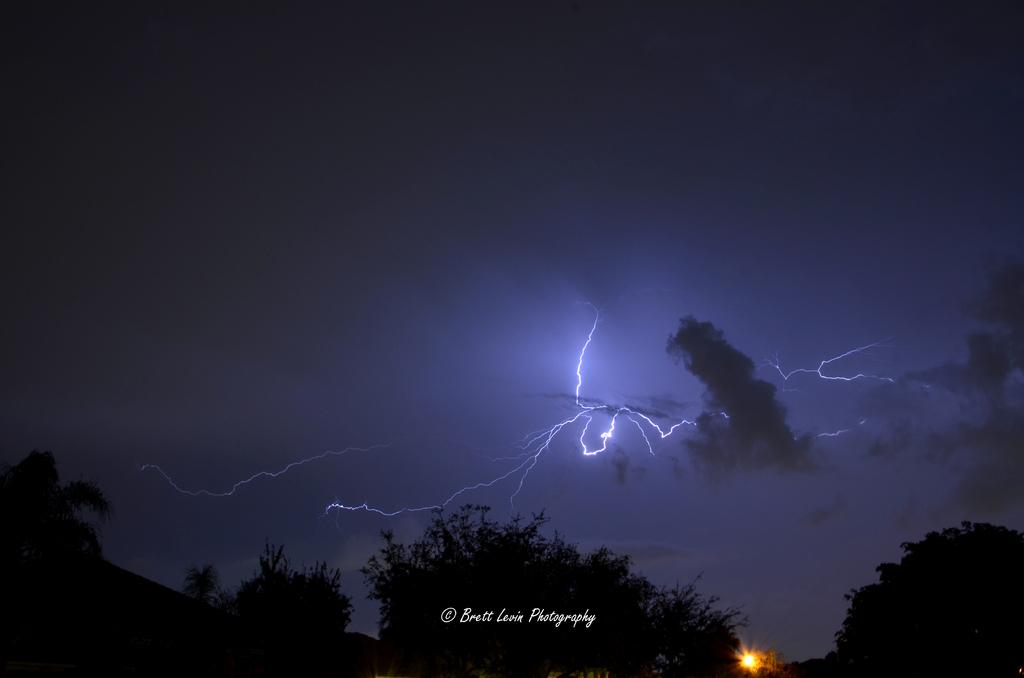What type of vegetation can be seen in the image? There are trees in the image. How would you describe the environment in which the trees are located? The trees are in a dark environment. What is visible in the sky in the image? Thunderstorms and clouds are visible in the sky. Can you describe the weather conditions in the image? The presence of thunderstorms suggests that it is stormy or rainy in the image. What type of cream can be seen on the leaves of the trees in the image? There is no cream visible on the leaves of the trees in the image. Can you see a sailboat navigating through the storm in the image? There is no sailboat or any other watercraft visible in the image. 